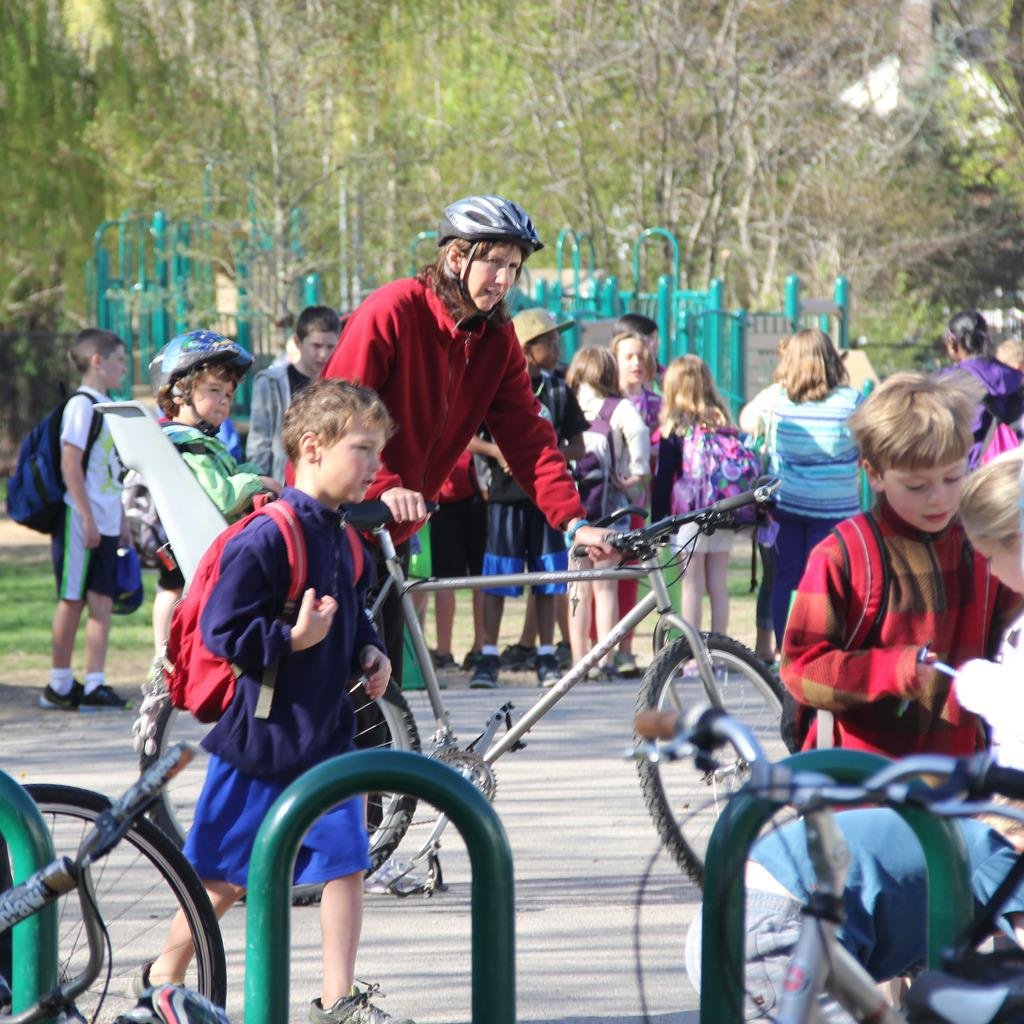What are the children doing in the image? The children are standing on either side of the road. Can you describe the boy in the image? The boy is walking with a backpack. What is the woman doing in the image? The woman is standing with a bicycle. What type of stone is the boy using to breathe in the image? There is no stone or breathing depicted in the image; the boy is simply walking with a backpack. 